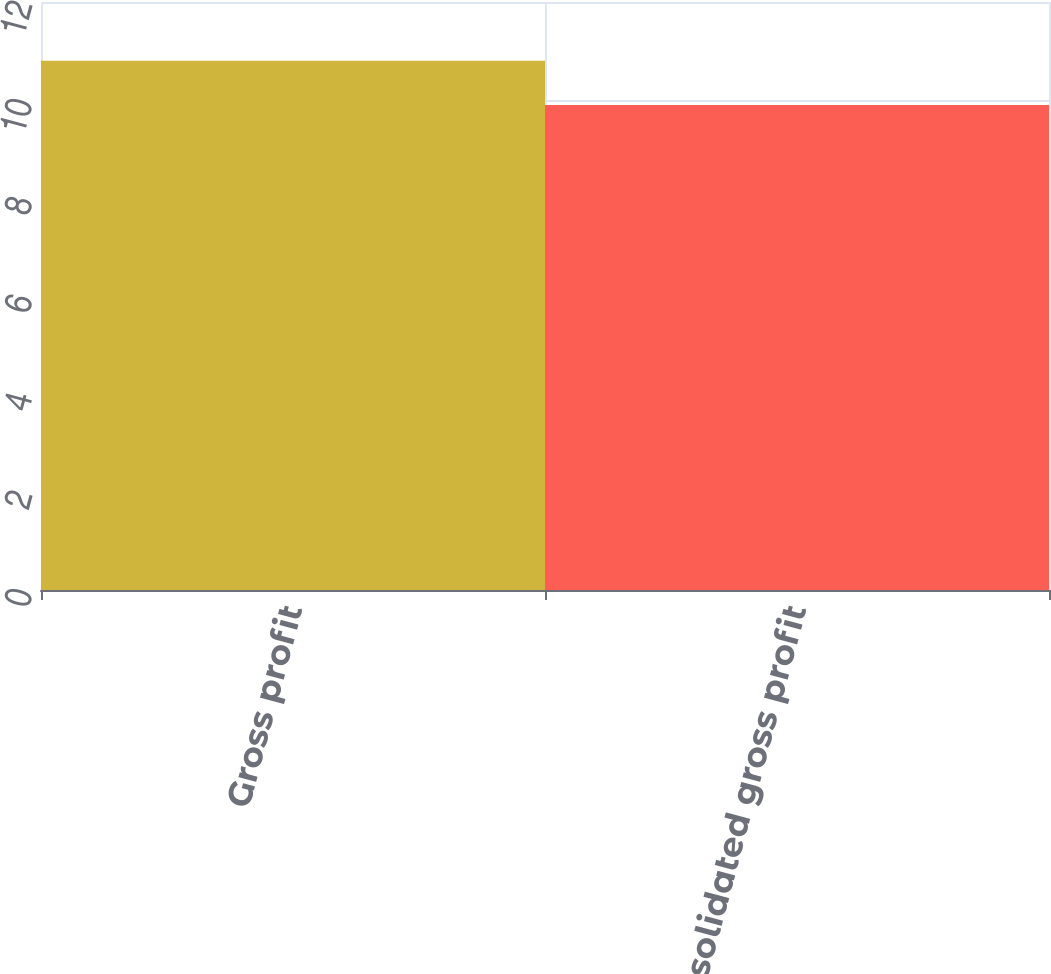<chart> <loc_0><loc_0><loc_500><loc_500><bar_chart><fcel>Gross profit<fcel>Consolidated gross profit<nl><fcel>10.8<fcel>9.9<nl></chart> 